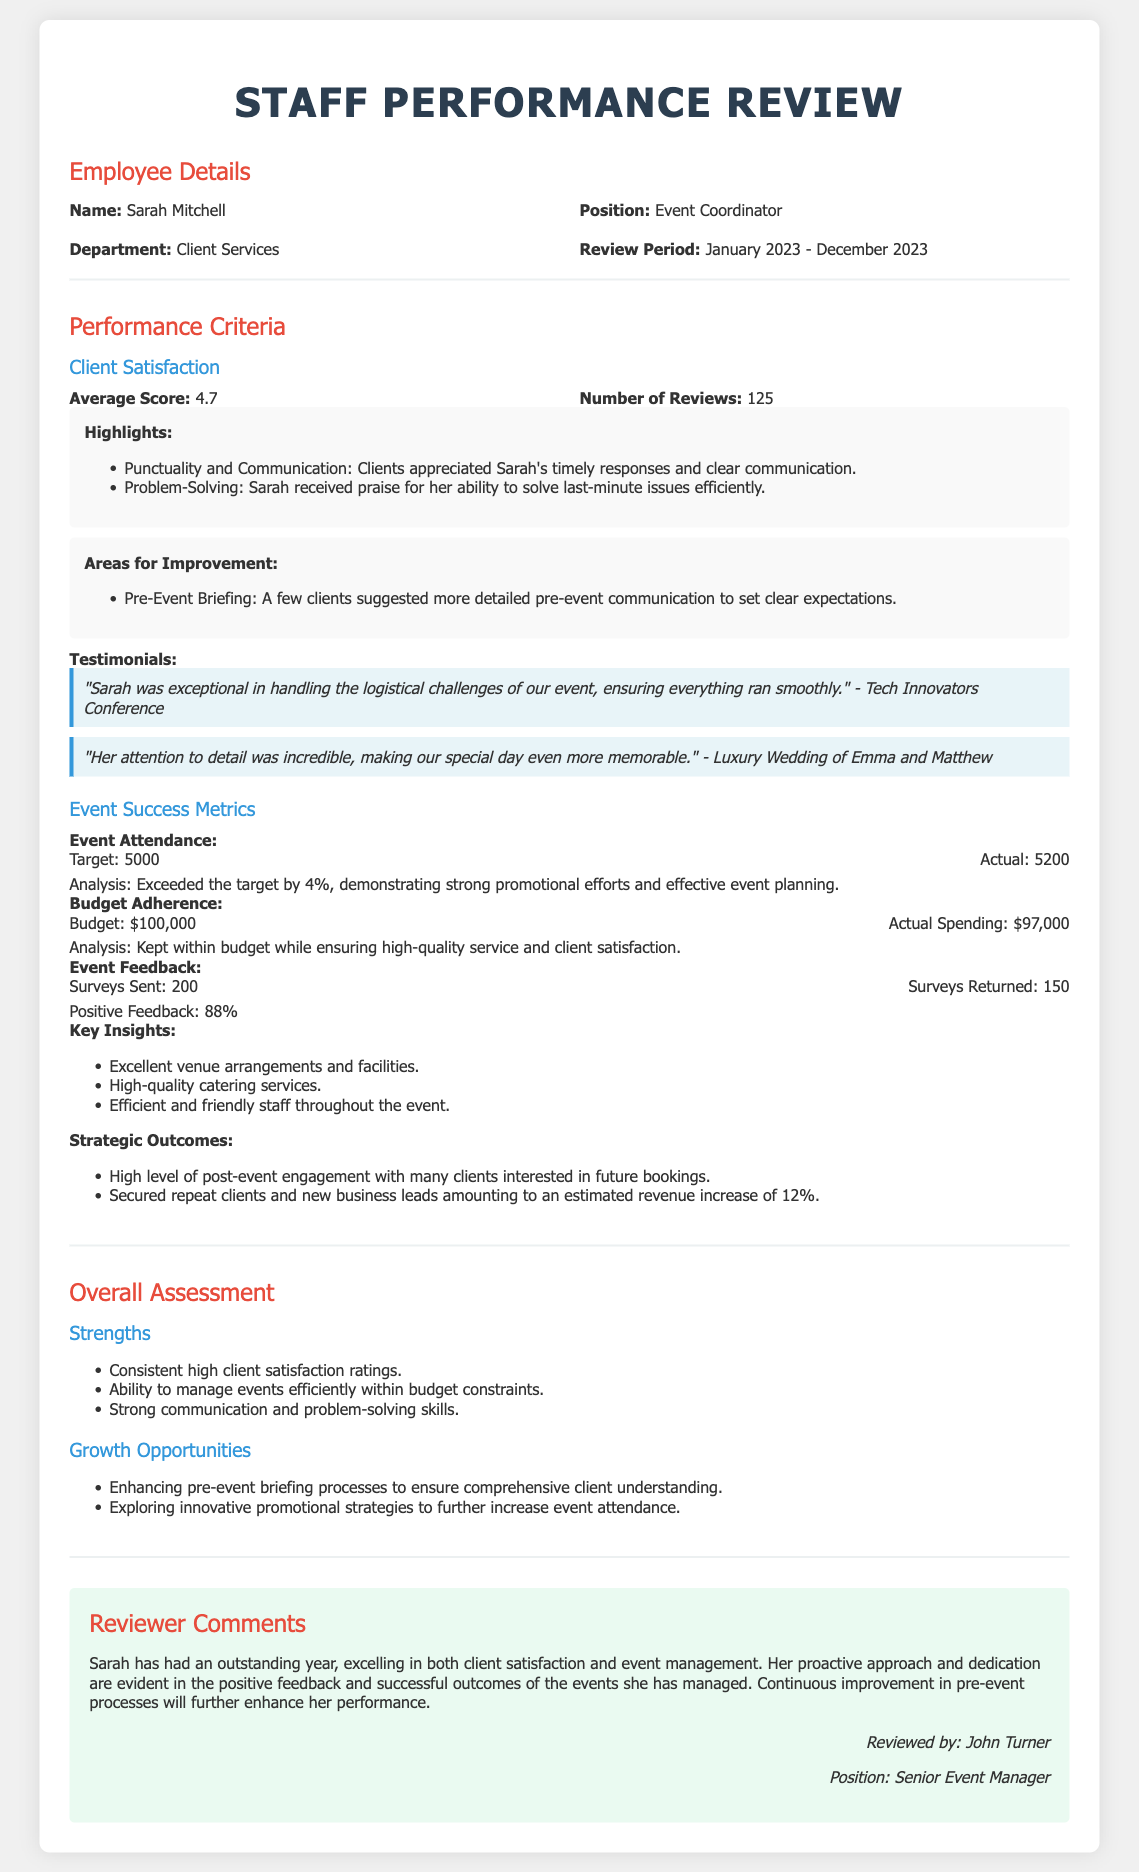What is the name of the employee being reviewed? The employee's name is mentioned in the "Employee Details" section of the document.
Answer: Sarah Mitchell What is the average client satisfaction score? The average score is provided in the "Client Satisfaction" subsection of the document.
Answer: 4.7 How many reviews were conducted for Sarah? The total number of reviews is specified in the "Client Satisfaction" section of the document.
Answer: 125 What was the actual attendance at the events organized? The actual attendance is provided in the "Event Success Metrics" section of the document.
Answer: 5200 What percentage of positive feedback was received from surveys? The percentage of positive feedback is mentioned in the "Event Feedback" subsection of the document.
Answer: 88% What is one area for improvement identified for Sarah? An area for improvement is listed in the "Areas for Improvement" highlight within the "Client Satisfaction" section.
Answer: Pre-Event Briefing What is the budget for the events? The budget is mentioned in the "Budget Adherence" subsection of the "Event Success Metrics" section.
Answer: $100,000 Who reviewed Sarah's performance? The reviewer's name is provided in the "Reviewer Comments" section of the document.
Answer: John Turner What was the revenue increase estimated from new business leads? The estimated revenue increase is stated in the "Strategic Outcomes" subsection of the document.
Answer: 12% 